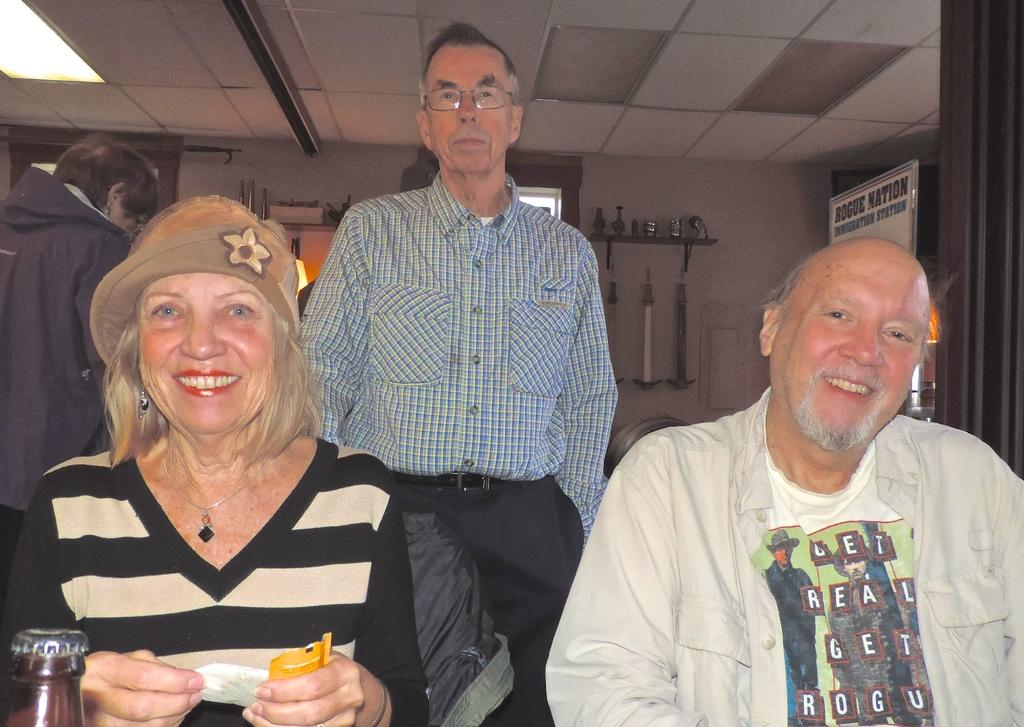Provide a one-sentence caption for the provided image. All smiles at the Rogue Nation get together!. 